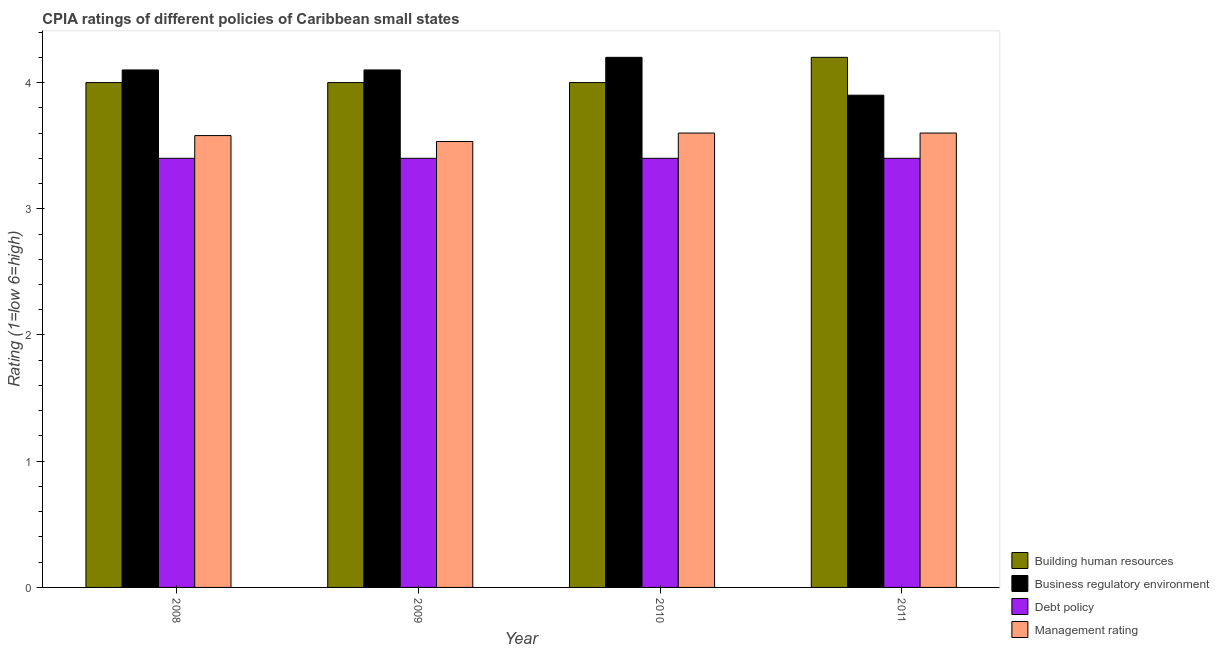Are the number of bars on each tick of the X-axis equal?
Keep it short and to the point. Yes. How many bars are there on the 1st tick from the left?
Offer a very short reply. 4. How many bars are there on the 2nd tick from the right?
Provide a short and direct response. 4. What is the cpia rating of debt policy in 2010?
Keep it short and to the point. 3.4. Across all years, what is the minimum cpia rating of management?
Offer a very short reply. 3.53. In which year was the cpia rating of debt policy maximum?
Your response must be concise. 2008. In which year was the cpia rating of building human resources minimum?
Make the answer very short. 2008. What is the difference between the cpia rating of business regulatory environment in 2008 and that in 2010?
Give a very brief answer. -0.1. What is the difference between the cpia rating of debt policy in 2010 and the cpia rating of building human resources in 2011?
Keep it short and to the point. 0. What is the average cpia rating of management per year?
Your response must be concise. 3.58. In the year 2010, what is the difference between the cpia rating of debt policy and cpia rating of business regulatory environment?
Your response must be concise. 0. What is the difference between the highest and the second highest cpia rating of debt policy?
Your answer should be very brief. 0. Is the sum of the cpia rating of building human resources in 2009 and 2010 greater than the maximum cpia rating of business regulatory environment across all years?
Make the answer very short. Yes. What does the 1st bar from the left in 2009 represents?
Give a very brief answer. Building human resources. What does the 2nd bar from the right in 2010 represents?
Your answer should be compact. Debt policy. Is it the case that in every year, the sum of the cpia rating of building human resources and cpia rating of business regulatory environment is greater than the cpia rating of debt policy?
Offer a terse response. Yes. Does the graph contain grids?
Your answer should be compact. No. How are the legend labels stacked?
Ensure brevity in your answer.  Vertical. What is the title of the graph?
Provide a succinct answer. CPIA ratings of different policies of Caribbean small states. What is the Rating (1=low 6=high) in Building human resources in 2008?
Give a very brief answer. 4. What is the Rating (1=low 6=high) of Business regulatory environment in 2008?
Your response must be concise. 4.1. What is the Rating (1=low 6=high) of Management rating in 2008?
Provide a succinct answer. 3.58. What is the Rating (1=low 6=high) in Building human resources in 2009?
Provide a short and direct response. 4. What is the Rating (1=low 6=high) in Debt policy in 2009?
Offer a very short reply. 3.4. What is the Rating (1=low 6=high) in Management rating in 2009?
Offer a very short reply. 3.53. What is the Rating (1=low 6=high) in Business regulatory environment in 2010?
Offer a very short reply. 4.2. What is the Rating (1=low 6=high) in Debt policy in 2011?
Keep it short and to the point. 3.4. Across all years, what is the maximum Rating (1=low 6=high) of Business regulatory environment?
Your response must be concise. 4.2. Across all years, what is the maximum Rating (1=low 6=high) of Debt policy?
Offer a very short reply. 3.4. Across all years, what is the minimum Rating (1=low 6=high) in Business regulatory environment?
Keep it short and to the point. 3.9. Across all years, what is the minimum Rating (1=low 6=high) of Debt policy?
Make the answer very short. 3.4. Across all years, what is the minimum Rating (1=low 6=high) of Management rating?
Your response must be concise. 3.53. What is the total Rating (1=low 6=high) of Debt policy in the graph?
Offer a terse response. 13.6. What is the total Rating (1=low 6=high) of Management rating in the graph?
Your response must be concise. 14.31. What is the difference between the Rating (1=low 6=high) in Business regulatory environment in 2008 and that in 2009?
Keep it short and to the point. 0. What is the difference between the Rating (1=low 6=high) of Debt policy in 2008 and that in 2009?
Provide a short and direct response. 0. What is the difference between the Rating (1=low 6=high) of Management rating in 2008 and that in 2009?
Offer a terse response. 0.05. What is the difference between the Rating (1=low 6=high) in Debt policy in 2008 and that in 2010?
Make the answer very short. 0. What is the difference between the Rating (1=low 6=high) in Management rating in 2008 and that in 2010?
Ensure brevity in your answer.  -0.02. What is the difference between the Rating (1=low 6=high) in Business regulatory environment in 2008 and that in 2011?
Your response must be concise. 0.2. What is the difference between the Rating (1=low 6=high) of Management rating in 2008 and that in 2011?
Your response must be concise. -0.02. What is the difference between the Rating (1=low 6=high) in Debt policy in 2009 and that in 2010?
Offer a terse response. 0. What is the difference between the Rating (1=low 6=high) of Management rating in 2009 and that in 2010?
Give a very brief answer. -0.07. What is the difference between the Rating (1=low 6=high) in Business regulatory environment in 2009 and that in 2011?
Your response must be concise. 0.2. What is the difference between the Rating (1=low 6=high) of Management rating in 2009 and that in 2011?
Keep it short and to the point. -0.07. What is the difference between the Rating (1=low 6=high) in Building human resources in 2010 and that in 2011?
Your answer should be compact. -0.2. What is the difference between the Rating (1=low 6=high) in Debt policy in 2010 and that in 2011?
Make the answer very short. 0. What is the difference between the Rating (1=low 6=high) in Management rating in 2010 and that in 2011?
Offer a terse response. 0. What is the difference between the Rating (1=low 6=high) of Building human resources in 2008 and the Rating (1=low 6=high) of Business regulatory environment in 2009?
Provide a short and direct response. -0.1. What is the difference between the Rating (1=low 6=high) of Building human resources in 2008 and the Rating (1=low 6=high) of Debt policy in 2009?
Give a very brief answer. 0.6. What is the difference between the Rating (1=low 6=high) of Building human resources in 2008 and the Rating (1=low 6=high) of Management rating in 2009?
Provide a succinct answer. 0.47. What is the difference between the Rating (1=low 6=high) of Business regulatory environment in 2008 and the Rating (1=low 6=high) of Debt policy in 2009?
Make the answer very short. 0.7. What is the difference between the Rating (1=low 6=high) of Business regulatory environment in 2008 and the Rating (1=low 6=high) of Management rating in 2009?
Ensure brevity in your answer.  0.57. What is the difference between the Rating (1=low 6=high) in Debt policy in 2008 and the Rating (1=low 6=high) in Management rating in 2009?
Offer a very short reply. -0.13. What is the difference between the Rating (1=low 6=high) in Building human resources in 2008 and the Rating (1=low 6=high) in Management rating in 2010?
Provide a short and direct response. 0.4. What is the difference between the Rating (1=low 6=high) of Business regulatory environment in 2008 and the Rating (1=low 6=high) of Debt policy in 2010?
Your response must be concise. 0.7. What is the difference between the Rating (1=low 6=high) in Debt policy in 2008 and the Rating (1=low 6=high) in Management rating in 2010?
Ensure brevity in your answer.  -0.2. What is the difference between the Rating (1=low 6=high) of Building human resources in 2008 and the Rating (1=low 6=high) of Management rating in 2011?
Provide a succinct answer. 0.4. What is the difference between the Rating (1=low 6=high) in Business regulatory environment in 2008 and the Rating (1=low 6=high) in Management rating in 2011?
Ensure brevity in your answer.  0.5. What is the difference between the Rating (1=low 6=high) in Building human resources in 2009 and the Rating (1=low 6=high) in Business regulatory environment in 2010?
Give a very brief answer. -0.2. What is the difference between the Rating (1=low 6=high) in Building human resources in 2009 and the Rating (1=low 6=high) in Debt policy in 2010?
Give a very brief answer. 0.6. What is the difference between the Rating (1=low 6=high) of Building human resources in 2009 and the Rating (1=low 6=high) of Management rating in 2010?
Provide a succinct answer. 0.4. What is the difference between the Rating (1=low 6=high) in Building human resources in 2009 and the Rating (1=low 6=high) in Business regulatory environment in 2011?
Your response must be concise. 0.1. What is the difference between the Rating (1=low 6=high) of Building human resources in 2009 and the Rating (1=low 6=high) of Management rating in 2011?
Provide a succinct answer. 0.4. What is the difference between the Rating (1=low 6=high) of Debt policy in 2009 and the Rating (1=low 6=high) of Management rating in 2011?
Ensure brevity in your answer.  -0.2. What is the difference between the Rating (1=low 6=high) of Building human resources in 2010 and the Rating (1=low 6=high) of Business regulatory environment in 2011?
Your answer should be compact. 0.1. What is the difference between the Rating (1=low 6=high) in Building human resources in 2010 and the Rating (1=low 6=high) in Debt policy in 2011?
Give a very brief answer. 0.6. What is the difference between the Rating (1=low 6=high) in Building human resources in 2010 and the Rating (1=low 6=high) in Management rating in 2011?
Provide a succinct answer. 0.4. What is the difference between the Rating (1=low 6=high) in Business regulatory environment in 2010 and the Rating (1=low 6=high) in Debt policy in 2011?
Give a very brief answer. 0.8. What is the difference between the Rating (1=low 6=high) of Business regulatory environment in 2010 and the Rating (1=low 6=high) of Management rating in 2011?
Provide a short and direct response. 0.6. What is the difference between the Rating (1=low 6=high) in Debt policy in 2010 and the Rating (1=low 6=high) in Management rating in 2011?
Provide a short and direct response. -0.2. What is the average Rating (1=low 6=high) in Building human resources per year?
Keep it short and to the point. 4.05. What is the average Rating (1=low 6=high) of Business regulatory environment per year?
Your answer should be very brief. 4.08. What is the average Rating (1=low 6=high) in Debt policy per year?
Give a very brief answer. 3.4. What is the average Rating (1=low 6=high) of Management rating per year?
Keep it short and to the point. 3.58. In the year 2008, what is the difference between the Rating (1=low 6=high) of Building human resources and Rating (1=low 6=high) of Business regulatory environment?
Keep it short and to the point. -0.1. In the year 2008, what is the difference between the Rating (1=low 6=high) of Building human resources and Rating (1=low 6=high) of Management rating?
Make the answer very short. 0.42. In the year 2008, what is the difference between the Rating (1=low 6=high) of Business regulatory environment and Rating (1=low 6=high) of Debt policy?
Ensure brevity in your answer.  0.7. In the year 2008, what is the difference between the Rating (1=low 6=high) in Business regulatory environment and Rating (1=low 6=high) in Management rating?
Your answer should be very brief. 0.52. In the year 2008, what is the difference between the Rating (1=low 6=high) of Debt policy and Rating (1=low 6=high) of Management rating?
Your answer should be compact. -0.18. In the year 2009, what is the difference between the Rating (1=low 6=high) of Building human resources and Rating (1=low 6=high) of Business regulatory environment?
Your response must be concise. -0.1. In the year 2009, what is the difference between the Rating (1=low 6=high) of Building human resources and Rating (1=low 6=high) of Debt policy?
Your answer should be compact. 0.6. In the year 2009, what is the difference between the Rating (1=low 6=high) of Building human resources and Rating (1=low 6=high) of Management rating?
Keep it short and to the point. 0.47. In the year 2009, what is the difference between the Rating (1=low 6=high) in Business regulatory environment and Rating (1=low 6=high) in Management rating?
Give a very brief answer. 0.57. In the year 2009, what is the difference between the Rating (1=low 6=high) of Debt policy and Rating (1=low 6=high) of Management rating?
Your response must be concise. -0.13. In the year 2010, what is the difference between the Rating (1=low 6=high) in Building human resources and Rating (1=low 6=high) in Business regulatory environment?
Make the answer very short. -0.2. In the year 2010, what is the difference between the Rating (1=low 6=high) of Building human resources and Rating (1=low 6=high) of Debt policy?
Provide a short and direct response. 0.6. In the year 2010, what is the difference between the Rating (1=low 6=high) in Business regulatory environment and Rating (1=low 6=high) in Management rating?
Provide a succinct answer. 0.6. In the year 2011, what is the difference between the Rating (1=low 6=high) of Building human resources and Rating (1=low 6=high) of Business regulatory environment?
Your answer should be very brief. 0.3. In the year 2011, what is the difference between the Rating (1=low 6=high) in Building human resources and Rating (1=low 6=high) in Management rating?
Your answer should be very brief. 0.6. In the year 2011, what is the difference between the Rating (1=low 6=high) in Business regulatory environment and Rating (1=low 6=high) in Debt policy?
Provide a succinct answer. 0.5. In the year 2011, what is the difference between the Rating (1=low 6=high) of Business regulatory environment and Rating (1=low 6=high) of Management rating?
Your answer should be compact. 0.3. In the year 2011, what is the difference between the Rating (1=low 6=high) in Debt policy and Rating (1=low 6=high) in Management rating?
Your response must be concise. -0.2. What is the ratio of the Rating (1=low 6=high) of Business regulatory environment in 2008 to that in 2009?
Ensure brevity in your answer.  1. What is the ratio of the Rating (1=low 6=high) of Debt policy in 2008 to that in 2009?
Your answer should be very brief. 1. What is the ratio of the Rating (1=low 6=high) in Management rating in 2008 to that in 2009?
Offer a terse response. 1.01. What is the ratio of the Rating (1=low 6=high) of Building human resources in 2008 to that in 2010?
Keep it short and to the point. 1. What is the ratio of the Rating (1=low 6=high) of Business regulatory environment in 2008 to that in 2010?
Make the answer very short. 0.98. What is the ratio of the Rating (1=low 6=high) of Debt policy in 2008 to that in 2010?
Offer a very short reply. 1. What is the ratio of the Rating (1=low 6=high) of Business regulatory environment in 2008 to that in 2011?
Give a very brief answer. 1.05. What is the ratio of the Rating (1=low 6=high) of Debt policy in 2008 to that in 2011?
Provide a succinct answer. 1. What is the ratio of the Rating (1=low 6=high) in Management rating in 2008 to that in 2011?
Give a very brief answer. 0.99. What is the ratio of the Rating (1=low 6=high) in Building human resources in 2009 to that in 2010?
Offer a very short reply. 1. What is the ratio of the Rating (1=low 6=high) of Business regulatory environment in 2009 to that in 2010?
Provide a short and direct response. 0.98. What is the ratio of the Rating (1=low 6=high) of Debt policy in 2009 to that in 2010?
Your answer should be very brief. 1. What is the ratio of the Rating (1=low 6=high) in Management rating in 2009 to that in 2010?
Your response must be concise. 0.98. What is the ratio of the Rating (1=low 6=high) of Building human resources in 2009 to that in 2011?
Keep it short and to the point. 0.95. What is the ratio of the Rating (1=low 6=high) in Business regulatory environment in 2009 to that in 2011?
Give a very brief answer. 1.05. What is the ratio of the Rating (1=low 6=high) in Management rating in 2009 to that in 2011?
Your response must be concise. 0.98. What is the ratio of the Rating (1=low 6=high) in Building human resources in 2010 to that in 2011?
Offer a terse response. 0.95. What is the ratio of the Rating (1=low 6=high) in Debt policy in 2010 to that in 2011?
Your answer should be compact. 1. What is the ratio of the Rating (1=low 6=high) in Management rating in 2010 to that in 2011?
Make the answer very short. 1. What is the difference between the highest and the second highest Rating (1=low 6=high) of Building human resources?
Your response must be concise. 0.2. What is the difference between the highest and the second highest Rating (1=low 6=high) of Business regulatory environment?
Give a very brief answer. 0.1. What is the difference between the highest and the second highest Rating (1=low 6=high) in Debt policy?
Your answer should be very brief. 0. What is the difference between the highest and the lowest Rating (1=low 6=high) in Business regulatory environment?
Your response must be concise. 0.3. What is the difference between the highest and the lowest Rating (1=low 6=high) of Debt policy?
Provide a succinct answer. 0. What is the difference between the highest and the lowest Rating (1=low 6=high) in Management rating?
Give a very brief answer. 0.07. 